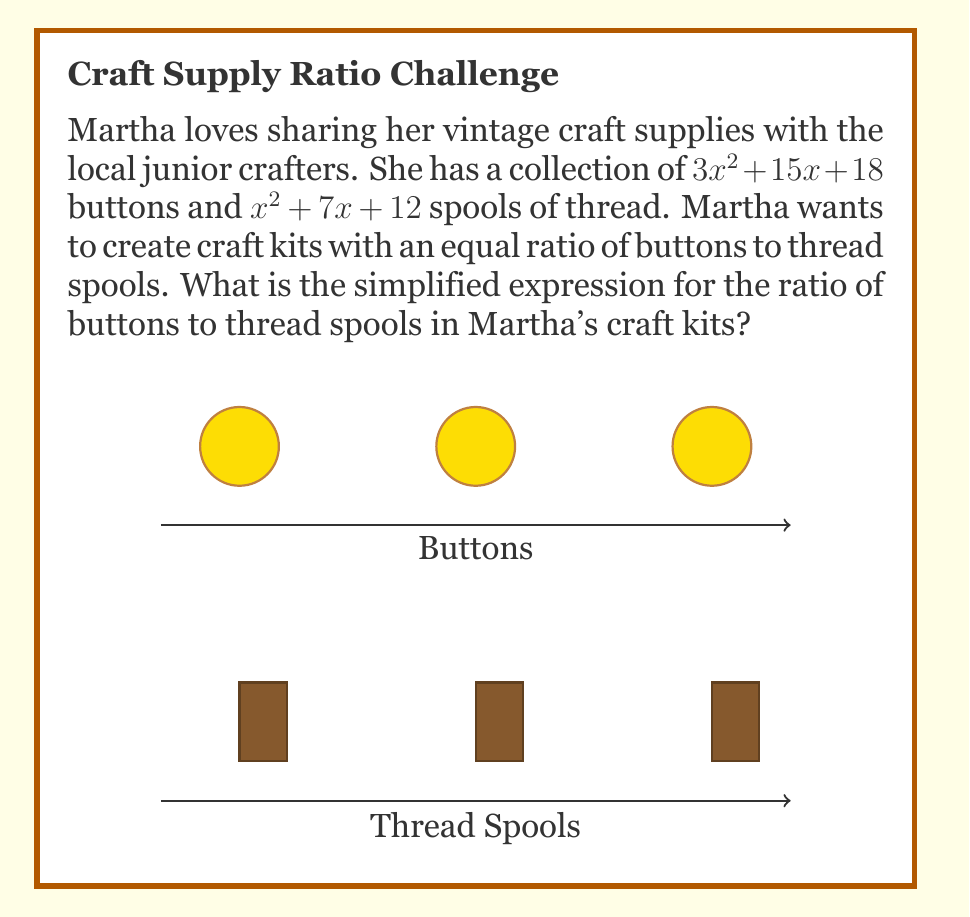Teach me how to tackle this problem. Let's simplify this rational expression step by step:

1) The ratio of buttons to thread spools is:
   $$\frac{3x^2 + 15x + 18}{x^2 + 7x + 12}$$

2) We need to factor both the numerator and denominator:
   
   Numerator: $3x^2 + 15x + 18 = 3(x^2 + 5x + 6) = 3(x + 2)(x + 3)$
   
   Denominator: $x^2 + 7x + 12 = (x + 3)(x + 4)$

3) Now our expression looks like:
   $$\frac{3(x + 2)(x + 3)}{(x + 3)(x + 4)}$$

4) We can cancel the common factor $(x + 3)$ from both numerator and denominator:
   $$\frac{3(x + 2)\cancel{(x + 3)}}{\cancel{(x + 3)}(x + 4)}$$

5) This simplifies to:
   $$\frac{3(x + 2)}{x + 4}$$

This is the simplified ratio of buttons to thread spools in Martha's craft kits.
Answer: $\frac{3(x + 2)}{x + 4}$ 